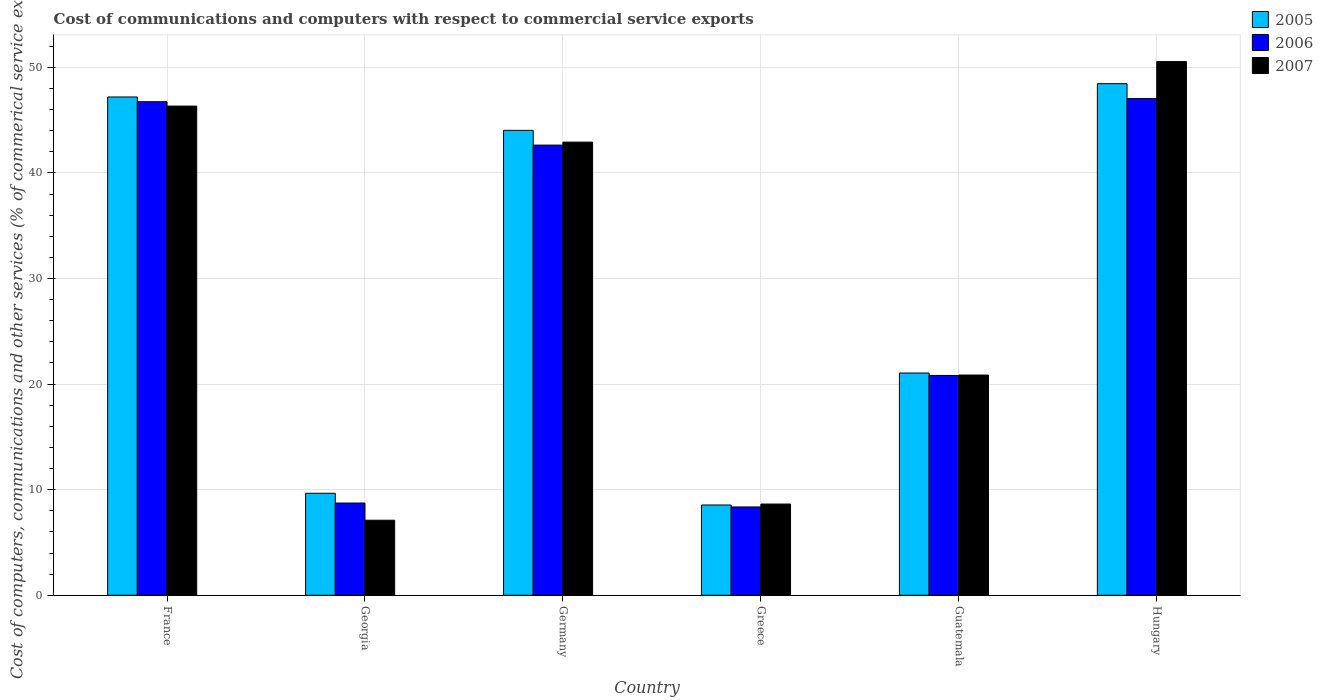How many different coloured bars are there?
Provide a short and direct response. 3. Are the number of bars per tick equal to the number of legend labels?
Your answer should be compact. Yes. How many bars are there on the 6th tick from the right?
Provide a succinct answer. 3. What is the label of the 1st group of bars from the left?
Your answer should be compact. France. In how many cases, is the number of bars for a given country not equal to the number of legend labels?
Give a very brief answer. 0. What is the cost of communications and computers in 2006 in France?
Provide a succinct answer. 46.74. Across all countries, what is the maximum cost of communications and computers in 2005?
Offer a very short reply. 48.46. Across all countries, what is the minimum cost of communications and computers in 2006?
Your answer should be very brief. 8.36. In which country was the cost of communications and computers in 2006 maximum?
Your answer should be compact. Hungary. What is the total cost of communications and computers in 2007 in the graph?
Offer a very short reply. 176.41. What is the difference between the cost of communications and computers in 2007 in France and that in Georgia?
Ensure brevity in your answer.  39.22. What is the difference between the cost of communications and computers in 2006 in Hungary and the cost of communications and computers in 2005 in France?
Ensure brevity in your answer.  -0.16. What is the average cost of communications and computers in 2006 per country?
Provide a short and direct response. 29.06. What is the difference between the cost of communications and computers of/in 2006 and cost of communications and computers of/in 2007 in France?
Keep it short and to the point. 0.41. In how many countries, is the cost of communications and computers in 2006 greater than 34 %?
Offer a terse response. 3. What is the ratio of the cost of communications and computers in 2005 in France to that in Germany?
Provide a short and direct response. 1.07. Is the difference between the cost of communications and computers in 2006 in Germany and Hungary greater than the difference between the cost of communications and computers in 2007 in Germany and Hungary?
Your answer should be compact. Yes. What is the difference between the highest and the second highest cost of communications and computers in 2005?
Offer a very short reply. 4.42. What is the difference between the highest and the lowest cost of communications and computers in 2007?
Your response must be concise. 43.44. Is the sum of the cost of communications and computers in 2007 in France and Germany greater than the maximum cost of communications and computers in 2006 across all countries?
Your response must be concise. Yes. What does the 1st bar from the left in Georgia represents?
Offer a very short reply. 2005. What is the difference between two consecutive major ticks on the Y-axis?
Offer a terse response. 10. Are the values on the major ticks of Y-axis written in scientific E-notation?
Ensure brevity in your answer.  No. Where does the legend appear in the graph?
Your response must be concise. Top right. How many legend labels are there?
Your answer should be compact. 3. How are the legend labels stacked?
Your response must be concise. Vertical. What is the title of the graph?
Make the answer very short. Cost of communications and computers with respect to commercial service exports. Does "1989" appear as one of the legend labels in the graph?
Offer a terse response. No. What is the label or title of the X-axis?
Make the answer very short. Country. What is the label or title of the Y-axis?
Your response must be concise. Cost of computers, communications and other services (% of commerical service exports). What is the Cost of computers, communications and other services (% of commerical service exports) of 2005 in France?
Provide a short and direct response. 47.19. What is the Cost of computers, communications and other services (% of commerical service exports) in 2006 in France?
Make the answer very short. 46.74. What is the Cost of computers, communications and other services (% of commerical service exports) of 2007 in France?
Make the answer very short. 46.33. What is the Cost of computers, communications and other services (% of commerical service exports) in 2005 in Georgia?
Offer a very short reply. 9.66. What is the Cost of computers, communications and other services (% of commerical service exports) of 2006 in Georgia?
Provide a succinct answer. 8.74. What is the Cost of computers, communications and other services (% of commerical service exports) of 2007 in Georgia?
Offer a terse response. 7.11. What is the Cost of computers, communications and other services (% of commerical service exports) in 2005 in Germany?
Provide a succinct answer. 44.03. What is the Cost of computers, communications and other services (% of commerical service exports) in 2006 in Germany?
Provide a succinct answer. 42.64. What is the Cost of computers, communications and other services (% of commerical service exports) of 2007 in Germany?
Your response must be concise. 42.92. What is the Cost of computers, communications and other services (% of commerical service exports) in 2005 in Greece?
Provide a succinct answer. 8.55. What is the Cost of computers, communications and other services (% of commerical service exports) of 2006 in Greece?
Provide a succinct answer. 8.36. What is the Cost of computers, communications and other services (% of commerical service exports) in 2007 in Greece?
Your answer should be very brief. 8.64. What is the Cost of computers, communications and other services (% of commerical service exports) of 2005 in Guatemala?
Provide a succinct answer. 21.05. What is the Cost of computers, communications and other services (% of commerical service exports) in 2006 in Guatemala?
Make the answer very short. 20.82. What is the Cost of computers, communications and other services (% of commerical service exports) of 2007 in Guatemala?
Provide a short and direct response. 20.86. What is the Cost of computers, communications and other services (% of commerical service exports) in 2005 in Hungary?
Your answer should be very brief. 48.46. What is the Cost of computers, communications and other services (% of commerical service exports) in 2006 in Hungary?
Keep it short and to the point. 47.04. What is the Cost of computers, communications and other services (% of commerical service exports) of 2007 in Hungary?
Provide a short and direct response. 50.55. Across all countries, what is the maximum Cost of computers, communications and other services (% of commerical service exports) in 2005?
Offer a very short reply. 48.46. Across all countries, what is the maximum Cost of computers, communications and other services (% of commerical service exports) of 2006?
Your answer should be very brief. 47.04. Across all countries, what is the maximum Cost of computers, communications and other services (% of commerical service exports) in 2007?
Make the answer very short. 50.55. Across all countries, what is the minimum Cost of computers, communications and other services (% of commerical service exports) in 2005?
Keep it short and to the point. 8.55. Across all countries, what is the minimum Cost of computers, communications and other services (% of commerical service exports) in 2006?
Give a very brief answer. 8.36. Across all countries, what is the minimum Cost of computers, communications and other services (% of commerical service exports) of 2007?
Keep it short and to the point. 7.11. What is the total Cost of computers, communications and other services (% of commerical service exports) in 2005 in the graph?
Your response must be concise. 178.94. What is the total Cost of computers, communications and other services (% of commerical service exports) of 2006 in the graph?
Your response must be concise. 174.34. What is the total Cost of computers, communications and other services (% of commerical service exports) of 2007 in the graph?
Make the answer very short. 176.41. What is the difference between the Cost of computers, communications and other services (% of commerical service exports) in 2005 in France and that in Georgia?
Provide a succinct answer. 37.53. What is the difference between the Cost of computers, communications and other services (% of commerical service exports) in 2006 in France and that in Georgia?
Keep it short and to the point. 38.01. What is the difference between the Cost of computers, communications and other services (% of commerical service exports) of 2007 in France and that in Georgia?
Provide a succinct answer. 39.22. What is the difference between the Cost of computers, communications and other services (% of commerical service exports) in 2005 in France and that in Germany?
Your answer should be compact. 3.16. What is the difference between the Cost of computers, communications and other services (% of commerical service exports) of 2006 in France and that in Germany?
Your answer should be very brief. 4.11. What is the difference between the Cost of computers, communications and other services (% of commerical service exports) of 2007 in France and that in Germany?
Your answer should be compact. 3.41. What is the difference between the Cost of computers, communications and other services (% of commerical service exports) of 2005 in France and that in Greece?
Your answer should be compact. 38.64. What is the difference between the Cost of computers, communications and other services (% of commerical service exports) in 2006 in France and that in Greece?
Offer a very short reply. 38.38. What is the difference between the Cost of computers, communications and other services (% of commerical service exports) in 2007 in France and that in Greece?
Ensure brevity in your answer.  37.69. What is the difference between the Cost of computers, communications and other services (% of commerical service exports) of 2005 in France and that in Guatemala?
Make the answer very short. 26.14. What is the difference between the Cost of computers, communications and other services (% of commerical service exports) in 2006 in France and that in Guatemala?
Your response must be concise. 25.92. What is the difference between the Cost of computers, communications and other services (% of commerical service exports) of 2007 in France and that in Guatemala?
Your response must be concise. 25.47. What is the difference between the Cost of computers, communications and other services (% of commerical service exports) in 2005 in France and that in Hungary?
Your answer should be compact. -1.26. What is the difference between the Cost of computers, communications and other services (% of commerical service exports) of 2006 in France and that in Hungary?
Provide a short and direct response. -0.3. What is the difference between the Cost of computers, communications and other services (% of commerical service exports) in 2007 in France and that in Hungary?
Your answer should be very brief. -4.22. What is the difference between the Cost of computers, communications and other services (% of commerical service exports) in 2005 in Georgia and that in Germany?
Provide a short and direct response. -34.37. What is the difference between the Cost of computers, communications and other services (% of commerical service exports) in 2006 in Georgia and that in Germany?
Ensure brevity in your answer.  -33.9. What is the difference between the Cost of computers, communications and other services (% of commerical service exports) of 2007 in Georgia and that in Germany?
Make the answer very short. -35.81. What is the difference between the Cost of computers, communications and other services (% of commerical service exports) in 2005 in Georgia and that in Greece?
Ensure brevity in your answer.  1.11. What is the difference between the Cost of computers, communications and other services (% of commerical service exports) of 2006 in Georgia and that in Greece?
Provide a short and direct response. 0.37. What is the difference between the Cost of computers, communications and other services (% of commerical service exports) of 2007 in Georgia and that in Greece?
Your answer should be compact. -1.53. What is the difference between the Cost of computers, communications and other services (% of commerical service exports) in 2005 in Georgia and that in Guatemala?
Offer a terse response. -11.39. What is the difference between the Cost of computers, communications and other services (% of commerical service exports) of 2006 in Georgia and that in Guatemala?
Your answer should be compact. -12.08. What is the difference between the Cost of computers, communications and other services (% of commerical service exports) of 2007 in Georgia and that in Guatemala?
Offer a terse response. -13.75. What is the difference between the Cost of computers, communications and other services (% of commerical service exports) in 2005 in Georgia and that in Hungary?
Keep it short and to the point. -38.8. What is the difference between the Cost of computers, communications and other services (% of commerical service exports) in 2006 in Georgia and that in Hungary?
Ensure brevity in your answer.  -38.3. What is the difference between the Cost of computers, communications and other services (% of commerical service exports) in 2007 in Georgia and that in Hungary?
Your answer should be compact. -43.44. What is the difference between the Cost of computers, communications and other services (% of commerical service exports) in 2005 in Germany and that in Greece?
Your answer should be very brief. 35.48. What is the difference between the Cost of computers, communications and other services (% of commerical service exports) of 2006 in Germany and that in Greece?
Offer a very short reply. 34.27. What is the difference between the Cost of computers, communications and other services (% of commerical service exports) in 2007 in Germany and that in Greece?
Give a very brief answer. 34.28. What is the difference between the Cost of computers, communications and other services (% of commerical service exports) of 2005 in Germany and that in Guatemala?
Offer a terse response. 22.98. What is the difference between the Cost of computers, communications and other services (% of commerical service exports) of 2006 in Germany and that in Guatemala?
Give a very brief answer. 21.82. What is the difference between the Cost of computers, communications and other services (% of commerical service exports) in 2007 in Germany and that in Guatemala?
Offer a terse response. 22.06. What is the difference between the Cost of computers, communications and other services (% of commerical service exports) of 2005 in Germany and that in Hungary?
Make the answer very short. -4.42. What is the difference between the Cost of computers, communications and other services (% of commerical service exports) of 2006 in Germany and that in Hungary?
Provide a succinct answer. -4.4. What is the difference between the Cost of computers, communications and other services (% of commerical service exports) in 2007 in Germany and that in Hungary?
Your answer should be very brief. -7.63. What is the difference between the Cost of computers, communications and other services (% of commerical service exports) in 2005 in Greece and that in Guatemala?
Provide a succinct answer. -12.5. What is the difference between the Cost of computers, communications and other services (% of commerical service exports) in 2006 in Greece and that in Guatemala?
Make the answer very short. -12.45. What is the difference between the Cost of computers, communications and other services (% of commerical service exports) of 2007 in Greece and that in Guatemala?
Make the answer very short. -12.22. What is the difference between the Cost of computers, communications and other services (% of commerical service exports) in 2005 in Greece and that in Hungary?
Give a very brief answer. -39.91. What is the difference between the Cost of computers, communications and other services (% of commerical service exports) in 2006 in Greece and that in Hungary?
Make the answer very short. -38.67. What is the difference between the Cost of computers, communications and other services (% of commerical service exports) of 2007 in Greece and that in Hungary?
Provide a short and direct response. -41.91. What is the difference between the Cost of computers, communications and other services (% of commerical service exports) in 2005 in Guatemala and that in Hungary?
Ensure brevity in your answer.  -27.41. What is the difference between the Cost of computers, communications and other services (% of commerical service exports) of 2006 in Guatemala and that in Hungary?
Keep it short and to the point. -26.22. What is the difference between the Cost of computers, communications and other services (% of commerical service exports) in 2007 in Guatemala and that in Hungary?
Keep it short and to the point. -29.69. What is the difference between the Cost of computers, communications and other services (% of commerical service exports) in 2005 in France and the Cost of computers, communications and other services (% of commerical service exports) in 2006 in Georgia?
Ensure brevity in your answer.  38.46. What is the difference between the Cost of computers, communications and other services (% of commerical service exports) in 2005 in France and the Cost of computers, communications and other services (% of commerical service exports) in 2007 in Georgia?
Offer a terse response. 40.09. What is the difference between the Cost of computers, communications and other services (% of commerical service exports) in 2006 in France and the Cost of computers, communications and other services (% of commerical service exports) in 2007 in Georgia?
Keep it short and to the point. 39.64. What is the difference between the Cost of computers, communications and other services (% of commerical service exports) in 2005 in France and the Cost of computers, communications and other services (% of commerical service exports) in 2006 in Germany?
Keep it short and to the point. 4.56. What is the difference between the Cost of computers, communications and other services (% of commerical service exports) of 2005 in France and the Cost of computers, communications and other services (% of commerical service exports) of 2007 in Germany?
Give a very brief answer. 4.28. What is the difference between the Cost of computers, communications and other services (% of commerical service exports) in 2006 in France and the Cost of computers, communications and other services (% of commerical service exports) in 2007 in Germany?
Keep it short and to the point. 3.83. What is the difference between the Cost of computers, communications and other services (% of commerical service exports) of 2005 in France and the Cost of computers, communications and other services (% of commerical service exports) of 2006 in Greece?
Offer a terse response. 38.83. What is the difference between the Cost of computers, communications and other services (% of commerical service exports) in 2005 in France and the Cost of computers, communications and other services (% of commerical service exports) in 2007 in Greece?
Provide a short and direct response. 38.55. What is the difference between the Cost of computers, communications and other services (% of commerical service exports) in 2006 in France and the Cost of computers, communications and other services (% of commerical service exports) in 2007 in Greece?
Your answer should be very brief. 38.1. What is the difference between the Cost of computers, communications and other services (% of commerical service exports) in 2005 in France and the Cost of computers, communications and other services (% of commerical service exports) in 2006 in Guatemala?
Ensure brevity in your answer.  26.37. What is the difference between the Cost of computers, communications and other services (% of commerical service exports) of 2005 in France and the Cost of computers, communications and other services (% of commerical service exports) of 2007 in Guatemala?
Provide a succinct answer. 26.33. What is the difference between the Cost of computers, communications and other services (% of commerical service exports) of 2006 in France and the Cost of computers, communications and other services (% of commerical service exports) of 2007 in Guatemala?
Make the answer very short. 25.88. What is the difference between the Cost of computers, communications and other services (% of commerical service exports) in 2005 in France and the Cost of computers, communications and other services (% of commerical service exports) in 2006 in Hungary?
Offer a terse response. 0.16. What is the difference between the Cost of computers, communications and other services (% of commerical service exports) of 2005 in France and the Cost of computers, communications and other services (% of commerical service exports) of 2007 in Hungary?
Your response must be concise. -3.35. What is the difference between the Cost of computers, communications and other services (% of commerical service exports) in 2006 in France and the Cost of computers, communications and other services (% of commerical service exports) in 2007 in Hungary?
Provide a succinct answer. -3.8. What is the difference between the Cost of computers, communications and other services (% of commerical service exports) in 2005 in Georgia and the Cost of computers, communications and other services (% of commerical service exports) in 2006 in Germany?
Your answer should be compact. -32.98. What is the difference between the Cost of computers, communications and other services (% of commerical service exports) in 2005 in Georgia and the Cost of computers, communications and other services (% of commerical service exports) in 2007 in Germany?
Make the answer very short. -33.26. What is the difference between the Cost of computers, communications and other services (% of commerical service exports) of 2006 in Georgia and the Cost of computers, communications and other services (% of commerical service exports) of 2007 in Germany?
Your answer should be very brief. -34.18. What is the difference between the Cost of computers, communications and other services (% of commerical service exports) in 2005 in Georgia and the Cost of computers, communications and other services (% of commerical service exports) in 2006 in Greece?
Give a very brief answer. 1.3. What is the difference between the Cost of computers, communications and other services (% of commerical service exports) of 2005 in Georgia and the Cost of computers, communications and other services (% of commerical service exports) of 2007 in Greece?
Provide a succinct answer. 1.02. What is the difference between the Cost of computers, communications and other services (% of commerical service exports) in 2006 in Georgia and the Cost of computers, communications and other services (% of commerical service exports) in 2007 in Greece?
Provide a short and direct response. 0.1. What is the difference between the Cost of computers, communications and other services (% of commerical service exports) of 2005 in Georgia and the Cost of computers, communications and other services (% of commerical service exports) of 2006 in Guatemala?
Provide a short and direct response. -11.16. What is the difference between the Cost of computers, communications and other services (% of commerical service exports) of 2005 in Georgia and the Cost of computers, communications and other services (% of commerical service exports) of 2007 in Guatemala?
Ensure brevity in your answer.  -11.2. What is the difference between the Cost of computers, communications and other services (% of commerical service exports) of 2006 in Georgia and the Cost of computers, communications and other services (% of commerical service exports) of 2007 in Guatemala?
Your answer should be compact. -12.13. What is the difference between the Cost of computers, communications and other services (% of commerical service exports) in 2005 in Georgia and the Cost of computers, communications and other services (% of commerical service exports) in 2006 in Hungary?
Provide a succinct answer. -37.38. What is the difference between the Cost of computers, communications and other services (% of commerical service exports) of 2005 in Georgia and the Cost of computers, communications and other services (% of commerical service exports) of 2007 in Hungary?
Offer a terse response. -40.89. What is the difference between the Cost of computers, communications and other services (% of commerical service exports) in 2006 in Georgia and the Cost of computers, communications and other services (% of commerical service exports) in 2007 in Hungary?
Your answer should be very brief. -41.81. What is the difference between the Cost of computers, communications and other services (% of commerical service exports) in 2005 in Germany and the Cost of computers, communications and other services (% of commerical service exports) in 2006 in Greece?
Your response must be concise. 35.67. What is the difference between the Cost of computers, communications and other services (% of commerical service exports) in 2005 in Germany and the Cost of computers, communications and other services (% of commerical service exports) in 2007 in Greece?
Keep it short and to the point. 35.39. What is the difference between the Cost of computers, communications and other services (% of commerical service exports) in 2006 in Germany and the Cost of computers, communications and other services (% of commerical service exports) in 2007 in Greece?
Provide a succinct answer. 34. What is the difference between the Cost of computers, communications and other services (% of commerical service exports) of 2005 in Germany and the Cost of computers, communications and other services (% of commerical service exports) of 2006 in Guatemala?
Offer a very short reply. 23.21. What is the difference between the Cost of computers, communications and other services (% of commerical service exports) of 2005 in Germany and the Cost of computers, communications and other services (% of commerical service exports) of 2007 in Guatemala?
Ensure brevity in your answer.  23.17. What is the difference between the Cost of computers, communications and other services (% of commerical service exports) in 2006 in Germany and the Cost of computers, communications and other services (% of commerical service exports) in 2007 in Guatemala?
Ensure brevity in your answer.  21.78. What is the difference between the Cost of computers, communications and other services (% of commerical service exports) in 2005 in Germany and the Cost of computers, communications and other services (% of commerical service exports) in 2006 in Hungary?
Your answer should be very brief. -3.01. What is the difference between the Cost of computers, communications and other services (% of commerical service exports) of 2005 in Germany and the Cost of computers, communications and other services (% of commerical service exports) of 2007 in Hungary?
Provide a short and direct response. -6.52. What is the difference between the Cost of computers, communications and other services (% of commerical service exports) in 2006 in Germany and the Cost of computers, communications and other services (% of commerical service exports) in 2007 in Hungary?
Offer a terse response. -7.91. What is the difference between the Cost of computers, communications and other services (% of commerical service exports) in 2005 in Greece and the Cost of computers, communications and other services (% of commerical service exports) in 2006 in Guatemala?
Provide a short and direct response. -12.27. What is the difference between the Cost of computers, communications and other services (% of commerical service exports) of 2005 in Greece and the Cost of computers, communications and other services (% of commerical service exports) of 2007 in Guatemala?
Make the answer very short. -12.31. What is the difference between the Cost of computers, communications and other services (% of commerical service exports) in 2006 in Greece and the Cost of computers, communications and other services (% of commerical service exports) in 2007 in Guatemala?
Provide a succinct answer. -12.5. What is the difference between the Cost of computers, communications and other services (% of commerical service exports) of 2005 in Greece and the Cost of computers, communications and other services (% of commerical service exports) of 2006 in Hungary?
Your response must be concise. -38.49. What is the difference between the Cost of computers, communications and other services (% of commerical service exports) in 2005 in Greece and the Cost of computers, communications and other services (% of commerical service exports) in 2007 in Hungary?
Ensure brevity in your answer.  -42. What is the difference between the Cost of computers, communications and other services (% of commerical service exports) of 2006 in Greece and the Cost of computers, communications and other services (% of commerical service exports) of 2007 in Hungary?
Ensure brevity in your answer.  -42.18. What is the difference between the Cost of computers, communications and other services (% of commerical service exports) in 2005 in Guatemala and the Cost of computers, communications and other services (% of commerical service exports) in 2006 in Hungary?
Offer a very short reply. -25.99. What is the difference between the Cost of computers, communications and other services (% of commerical service exports) of 2005 in Guatemala and the Cost of computers, communications and other services (% of commerical service exports) of 2007 in Hungary?
Keep it short and to the point. -29.5. What is the difference between the Cost of computers, communications and other services (% of commerical service exports) of 2006 in Guatemala and the Cost of computers, communications and other services (% of commerical service exports) of 2007 in Hungary?
Your answer should be very brief. -29.73. What is the average Cost of computers, communications and other services (% of commerical service exports) in 2005 per country?
Offer a very short reply. 29.82. What is the average Cost of computers, communications and other services (% of commerical service exports) in 2006 per country?
Offer a terse response. 29.06. What is the average Cost of computers, communications and other services (% of commerical service exports) in 2007 per country?
Give a very brief answer. 29.4. What is the difference between the Cost of computers, communications and other services (% of commerical service exports) in 2005 and Cost of computers, communications and other services (% of commerical service exports) in 2006 in France?
Your answer should be compact. 0.45. What is the difference between the Cost of computers, communications and other services (% of commerical service exports) in 2005 and Cost of computers, communications and other services (% of commerical service exports) in 2007 in France?
Offer a very short reply. 0.86. What is the difference between the Cost of computers, communications and other services (% of commerical service exports) in 2006 and Cost of computers, communications and other services (% of commerical service exports) in 2007 in France?
Your response must be concise. 0.41. What is the difference between the Cost of computers, communications and other services (% of commerical service exports) in 2005 and Cost of computers, communications and other services (% of commerical service exports) in 2006 in Georgia?
Give a very brief answer. 0.93. What is the difference between the Cost of computers, communications and other services (% of commerical service exports) in 2005 and Cost of computers, communications and other services (% of commerical service exports) in 2007 in Georgia?
Provide a short and direct response. 2.55. What is the difference between the Cost of computers, communications and other services (% of commerical service exports) of 2006 and Cost of computers, communications and other services (% of commerical service exports) of 2007 in Georgia?
Make the answer very short. 1.63. What is the difference between the Cost of computers, communications and other services (% of commerical service exports) in 2005 and Cost of computers, communications and other services (% of commerical service exports) in 2006 in Germany?
Give a very brief answer. 1.4. What is the difference between the Cost of computers, communications and other services (% of commerical service exports) of 2005 and Cost of computers, communications and other services (% of commerical service exports) of 2007 in Germany?
Offer a terse response. 1.11. What is the difference between the Cost of computers, communications and other services (% of commerical service exports) in 2006 and Cost of computers, communications and other services (% of commerical service exports) in 2007 in Germany?
Provide a succinct answer. -0.28. What is the difference between the Cost of computers, communications and other services (% of commerical service exports) of 2005 and Cost of computers, communications and other services (% of commerical service exports) of 2006 in Greece?
Offer a terse response. 0.19. What is the difference between the Cost of computers, communications and other services (% of commerical service exports) in 2005 and Cost of computers, communications and other services (% of commerical service exports) in 2007 in Greece?
Make the answer very short. -0.09. What is the difference between the Cost of computers, communications and other services (% of commerical service exports) of 2006 and Cost of computers, communications and other services (% of commerical service exports) of 2007 in Greece?
Offer a very short reply. -0.28. What is the difference between the Cost of computers, communications and other services (% of commerical service exports) in 2005 and Cost of computers, communications and other services (% of commerical service exports) in 2006 in Guatemala?
Your response must be concise. 0.23. What is the difference between the Cost of computers, communications and other services (% of commerical service exports) of 2005 and Cost of computers, communications and other services (% of commerical service exports) of 2007 in Guatemala?
Give a very brief answer. 0.19. What is the difference between the Cost of computers, communications and other services (% of commerical service exports) in 2006 and Cost of computers, communications and other services (% of commerical service exports) in 2007 in Guatemala?
Ensure brevity in your answer.  -0.04. What is the difference between the Cost of computers, communications and other services (% of commerical service exports) in 2005 and Cost of computers, communications and other services (% of commerical service exports) in 2006 in Hungary?
Offer a very short reply. 1.42. What is the difference between the Cost of computers, communications and other services (% of commerical service exports) of 2005 and Cost of computers, communications and other services (% of commerical service exports) of 2007 in Hungary?
Your answer should be compact. -2.09. What is the difference between the Cost of computers, communications and other services (% of commerical service exports) in 2006 and Cost of computers, communications and other services (% of commerical service exports) in 2007 in Hungary?
Ensure brevity in your answer.  -3.51. What is the ratio of the Cost of computers, communications and other services (% of commerical service exports) of 2005 in France to that in Georgia?
Your response must be concise. 4.89. What is the ratio of the Cost of computers, communications and other services (% of commerical service exports) of 2006 in France to that in Georgia?
Offer a very short reply. 5.35. What is the ratio of the Cost of computers, communications and other services (% of commerical service exports) in 2007 in France to that in Georgia?
Your response must be concise. 6.52. What is the ratio of the Cost of computers, communications and other services (% of commerical service exports) in 2005 in France to that in Germany?
Offer a terse response. 1.07. What is the ratio of the Cost of computers, communications and other services (% of commerical service exports) in 2006 in France to that in Germany?
Your response must be concise. 1.1. What is the ratio of the Cost of computers, communications and other services (% of commerical service exports) of 2007 in France to that in Germany?
Provide a succinct answer. 1.08. What is the ratio of the Cost of computers, communications and other services (% of commerical service exports) of 2005 in France to that in Greece?
Your answer should be very brief. 5.52. What is the ratio of the Cost of computers, communications and other services (% of commerical service exports) of 2006 in France to that in Greece?
Your answer should be compact. 5.59. What is the ratio of the Cost of computers, communications and other services (% of commerical service exports) of 2007 in France to that in Greece?
Offer a very short reply. 5.36. What is the ratio of the Cost of computers, communications and other services (% of commerical service exports) in 2005 in France to that in Guatemala?
Your response must be concise. 2.24. What is the ratio of the Cost of computers, communications and other services (% of commerical service exports) of 2006 in France to that in Guatemala?
Provide a short and direct response. 2.25. What is the ratio of the Cost of computers, communications and other services (% of commerical service exports) in 2007 in France to that in Guatemala?
Offer a terse response. 2.22. What is the ratio of the Cost of computers, communications and other services (% of commerical service exports) in 2006 in France to that in Hungary?
Offer a terse response. 0.99. What is the ratio of the Cost of computers, communications and other services (% of commerical service exports) in 2007 in France to that in Hungary?
Your answer should be compact. 0.92. What is the ratio of the Cost of computers, communications and other services (% of commerical service exports) in 2005 in Georgia to that in Germany?
Give a very brief answer. 0.22. What is the ratio of the Cost of computers, communications and other services (% of commerical service exports) of 2006 in Georgia to that in Germany?
Give a very brief answer. 0.2. What is the ratio of the Cost of computers, communications and other services (% of commerical service exports) in 2007 in Georgia to that in Germany?
Provide a short and direct response. 0.17. What is the ratio of the Cost of computers, communications and other services (% of commerical service exports) in 2005 in Georgia to that in Greece?
Your response must be concise. 1.13. What is the ratio of the Cost of computers, communications and other services (% of commerical service exports) of 2006 in Georgia to that in Greece?
Offer a very short reply. 1.04. What is the ratio of the Cost of computers, communications and other services (% of commerical service exports) in 2007 in Georgia to that in Greece?
Provide a succinct answer. 0.82. What is the ratio of the Cost of computers, communications and other services (% of commerical service exports) of 2005 in Georgia to that in Guatemala?
Your answer should be compact. 0.46. What is the ratio of the Cost of computers, communications and other services (% of commerical service exports) in 2006 in Georgia to that in Guatemala?
Provide a short and direct response. 0.42. What is the ratio of the Cost of computers, communications and other services (% of commerical service exports) of 2007 in Georgia to that in Guatemala?
Provide a succinct answer. 0.34. What is the ratio of the Cost of computers, communications and other services (% of commerical service exports) of 2005 in Georgia to that in Hungary?
Offer a very short reply. 0.2. What is the ratio of the Cost of computers, communications and other services (% of commerical service exports) in 2006 in Georgia to that in Hungary?
Give a very brief answer. 0.19. What is the ratio of the Cost of computers, communications and other services (% of commerical service exports) of 2007 in Georgia to that in Hungary?
Your answer should be very brief. 0.14. What is the ratio of the Cost of computers, communications and other services (% of commerical service exports) in 2005 in Germany to that in Greece?
Offer a very short reply. 5.15. What is the ratio of the Cost of computers, communications and other services (% of commerical service exports) of 2006 in Germany to that in Greece?
Give a very brief answer. 5.1. What is the ratio of the Cost of computers, communications and other services (% of commerical service exports) in 2007 in Germany to that in Greece?
Offer a terse response. 4.97. What is the ratio of the Cost of computers, communications and other services (% of commerical service exports) of 2005 in Germany to that in Guatemala?
Your answer should be very brief. 2.09. What is the ratio of the Cost of computers, communications and other services (% of commerical service exports) of 2006 in Germany to that in Guatemala?
Give a very brief answer. 2.05. What is the ratio of the Cost of computers, communications and other services (% of commerical service exports) of 2007 in Germany to that in Guatemala?
Offer a terse response. 2.06. What is the ratio of the Cost of computers, communications and other services (% of commerical service exports) in 2005 in Germany to that in Hungary?
Your response must be concise. 0.91. What is the ratio of the Cost of computers, communications and other services (% of commerical service exports) of 2006 in Germany to that in Hungary?
Ensure brevity in your answer.  0.91. What is the ratio of the Cost of computers, communications and other services (% of commerical service exports) of 2007 in Germany to that in Hungary?
Provide a succinct answer. 0.85. What is the ratio of the Cost of computers, communications and other services (% of commerical service exports) of 2005 in Greece to that in Guatemala?
Give a very brief answer. 0.41. What is the ratio of the Cost of computers, communications and other services (% of commerical service exports) of 2006 in Greece to that in Guatemala?
Keep it short and to the point. 0.4. What is the ratio of the Cost of computers, communications and other services (% of commerical service exports) in 2007 in Greece to that in Guatemala?
Offer a terse response. 0.41. What is the ratio of the Cost of computers, communications and other services (% of commerical service exports) in 2005 in Greece to that in Hungary?
Make the answer very short. 0.18. What is the ratio of the Cost of computers, communications and other services (% of commerical service exports) of 2006 in Greece to that in Hungary?
Ensure brevity in your answer.  0.18. What is the ratio of the Cost of computers, communications and other services (% of commerical service exports) of 2007 in Greece to that in Hungary?
Offer a terse response. 0.17. What is the ratio of the Cost of computers, communications and other services (% of commerical service exports) in 2005 in Guatemala to that in Hungary?
Offer a very short reply. 0.43. What is the ratio of the Cost of computers, communications and other services (% of commerical service exports) in 2006 in Guatemala to that in Hungary?
Provide a short and direct response. 0.44. What is the ratio of the Cost of computers, communications and other services (% of commerical service exports) in 2007 in Guatemala to that in Hungary?
Your answer should be compact. 0.41. What is the difference between the highest and the second highest Cost of computers, communications and other services (% of commerical service exports) in 2005?
Provide a succinct answer. 1.26. What is the difference between the highest and the second highest Cost of computers, communications and other services (% of commerical service exports) in 2006?
Your answer should be compact. 0.3. What is the difference between the highest and the second highest Cost of computers, communications and other services (% of commerical service exports) of 2007?
Ensure brevity in your answer.  4.22. What is the difference between the highest and the lowest Cost of computers, communications and other services (% of commerical service exports) of 2005?
Your answer should be very brief. 39.91. What is the difference between the highest and the lowest Cost of computers, communications and other services (% of commerical service exports) in 2006?
Your answer should be compact. 38.67. What is the difference between the highest and the lowest Cost of computers, communications and other services (% of commerical service exports) in 2007?
Your answer should be very brief. 43.44. 